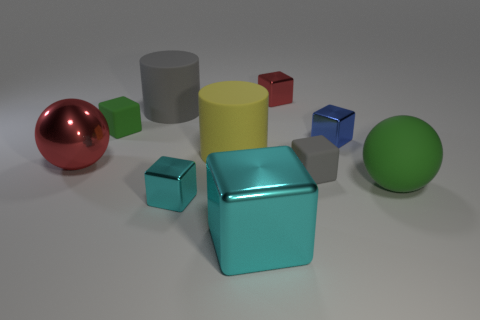Subtract all cyan blocks. How many were subtracted if there are1cyan blocks left? 1 Subtract all rubber cubes. How many cubes are left? 4 Subtract all cyan blocks. How many blocks are left? 4 Subtract all purple blocks. Subtract all gray spheres. How many blocks are left? 6 Subtract all cylinders. How many objects are left? 8 Add 1 small gray rubber spheres. How many small gray rubber spheres exist? 1 Subtract 0 purple cylinders. How many objects are left? 10 Subtract all tiny green things. Subtract all small green rubber things. How many objects are left? 8 Add 1 green rubber cubes. How many green rubber cubes are left? 2 